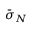<formula> <loc_0><loc_0><loc_500><loc_500>\bar { \sigma } _ { N }</formula> 